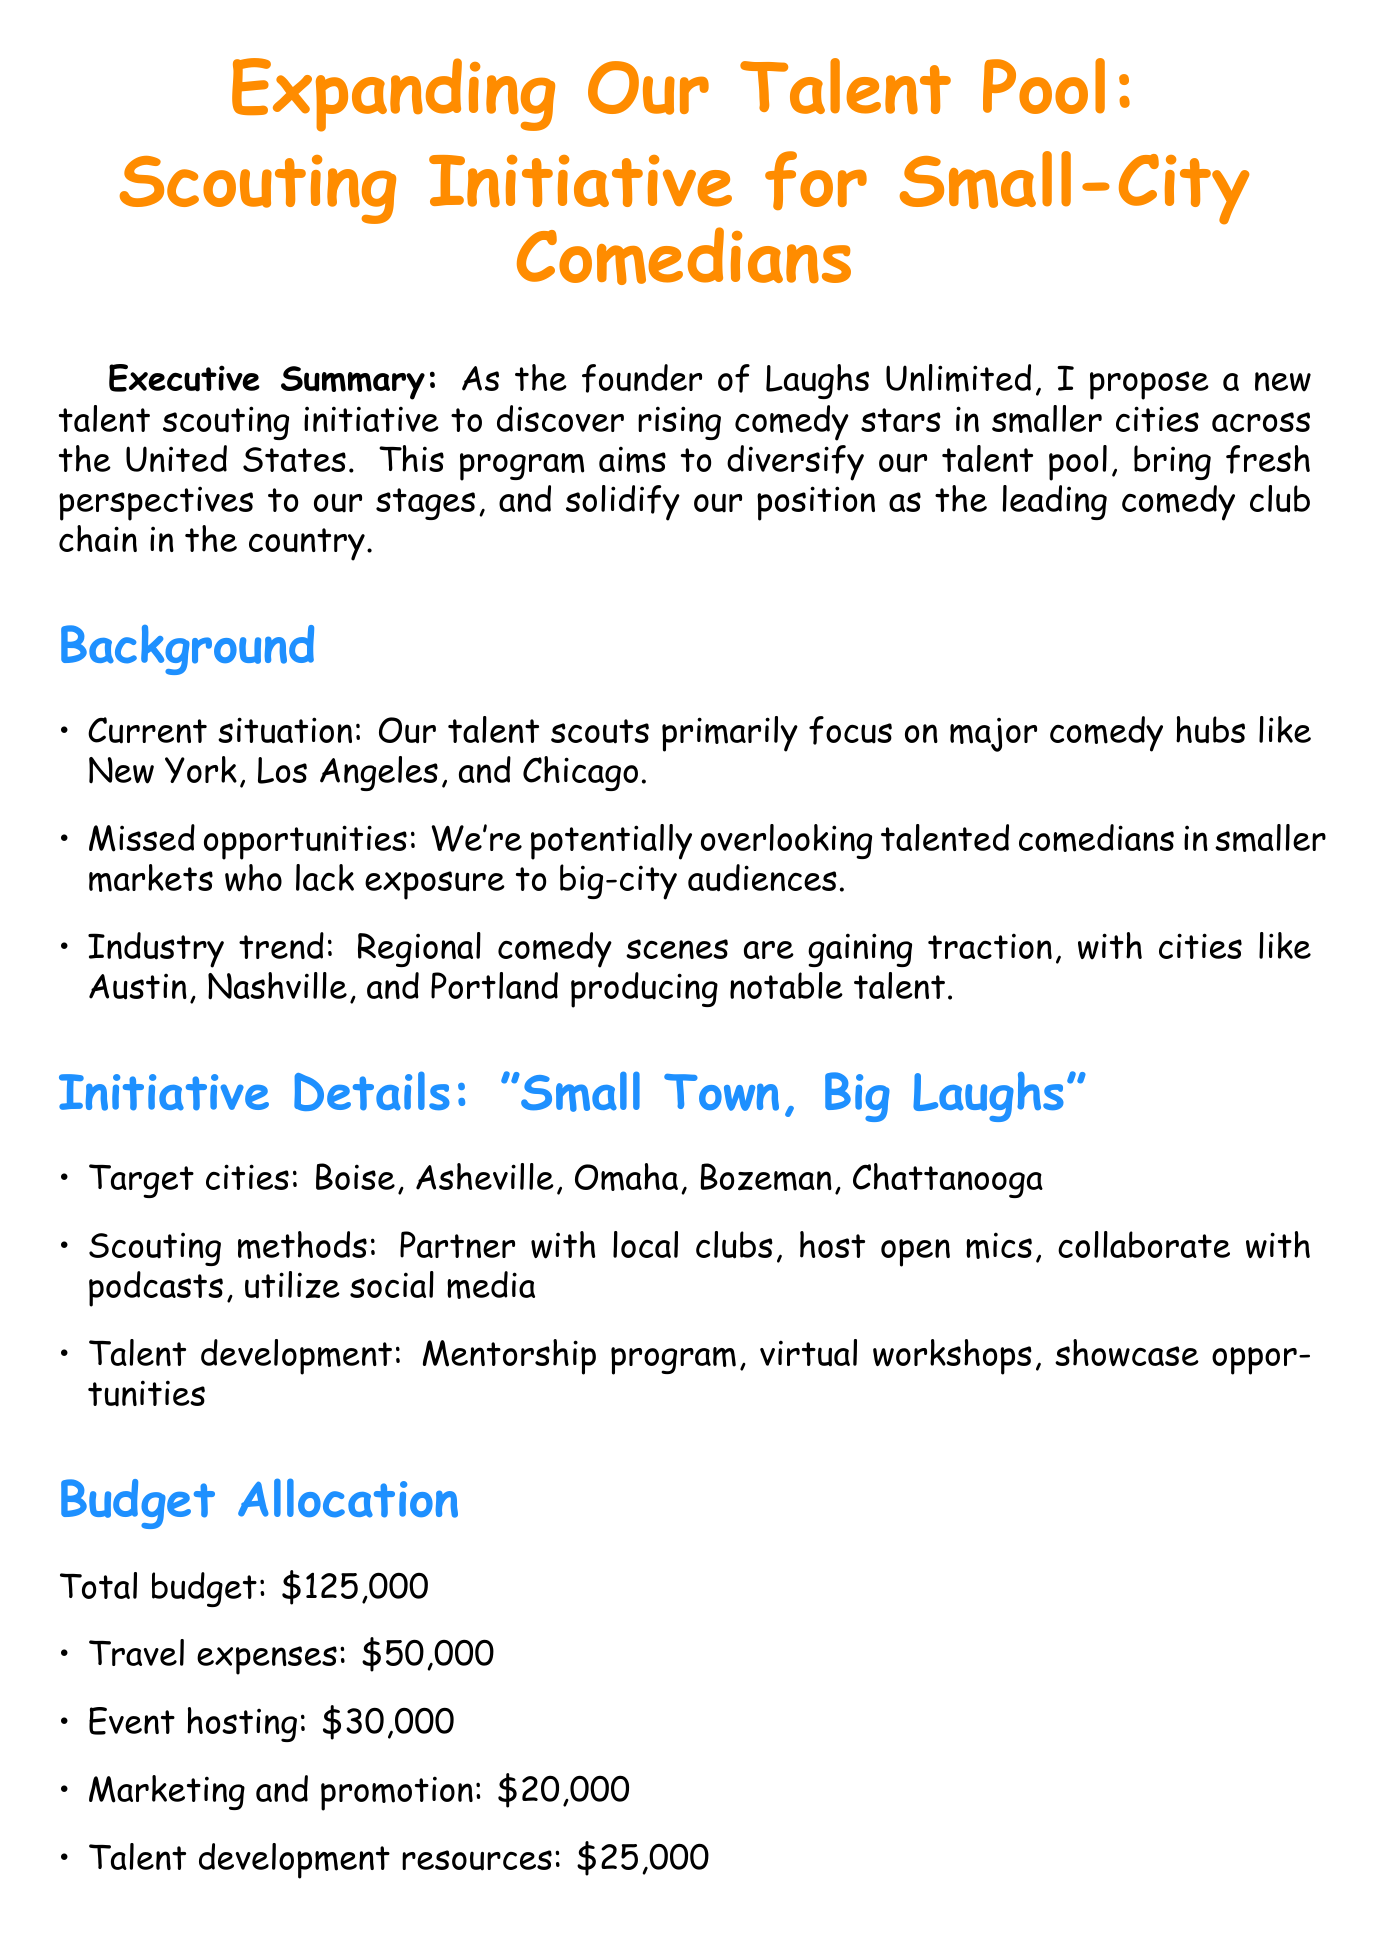What is the program name? The program name is explicitly mentioned in the initiative details as "Small Town, Big Laughs".
Answer: Small Town, Big Laughs What are the target cities? The document lists five specific target cities in the initiative details: Boise, Asheville, Omaha, Bozeman, and Chattanooga.
Answer: Boise, Asheville, Omaha, Bozeman, Chattanooga What is the total budget for the initiative? The total budget is stated clearly in the budget allocation section of the memo as $125,000.
Answer: $125,000 Who is the Head of Talent Acquisition? The key stakeholders section identifies Sarah Johnson as the Head of Talent Acquisition.
Answer: Sarah Johnson How many promising comedians does the initiative aim to discover in the first year? The expected outcomes specify discovering at least 10 promising comedians from smaller markets within the first year.
Answer: 10 What phase involves research and planning? The implementation timeline outlines Phase 1 as the phase that includes research and planning, taking 2 months.
Answer: Phase 1 What are the scouting methods mentioned? The initiative details outline various scouting methods, including partnering with local comedy clubs, hosting open mic nights, collaborating with podcasts, and utilizing social media.
Answer: Partner with local clubs, host open mics, collaborate with podcasts, utilize social media What is the expected increase in audience diversity? The expected outcomes indicate an increase in audience diversity across clubs by 15%.
Answer: 15% What is the goal regarding media coverage? The expected outcomes highlight the aim to generate positive press coverage in regional media outlets.
Answer: Positive press coverage 